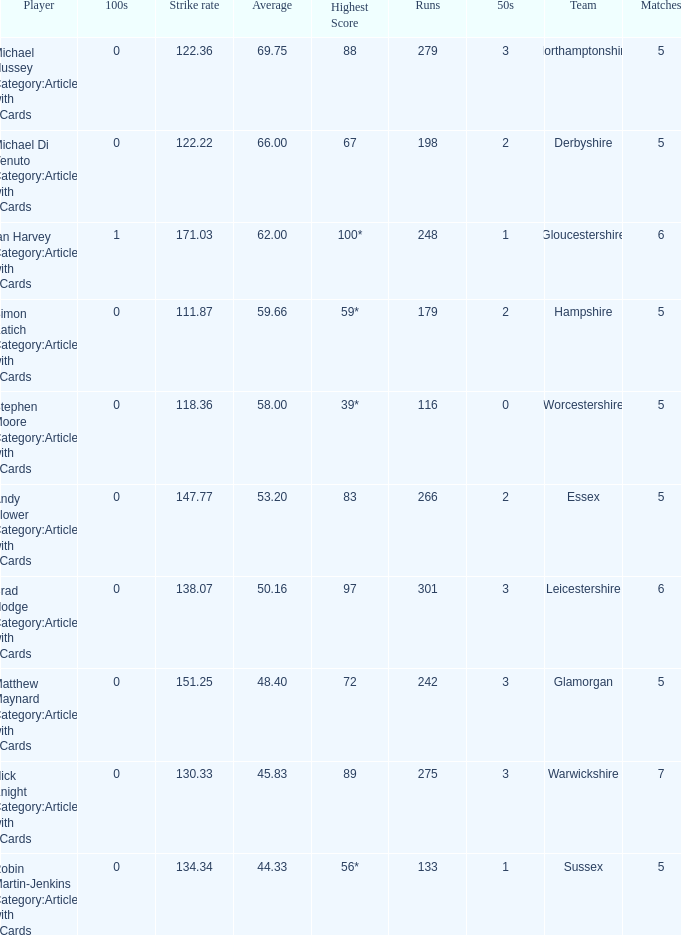If the average is 50.16, who is the player? Brad Hodge Category:Articles with hCards. 